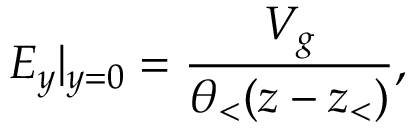Convert formula to latex. <formula><loc_0><loc_0><loc_500><loc_500>E _ { y } | _ { y = 0 } = \frac { V _ { g } } { \theta _ { < } ( z - z _ { < } ) } ,</formula> 